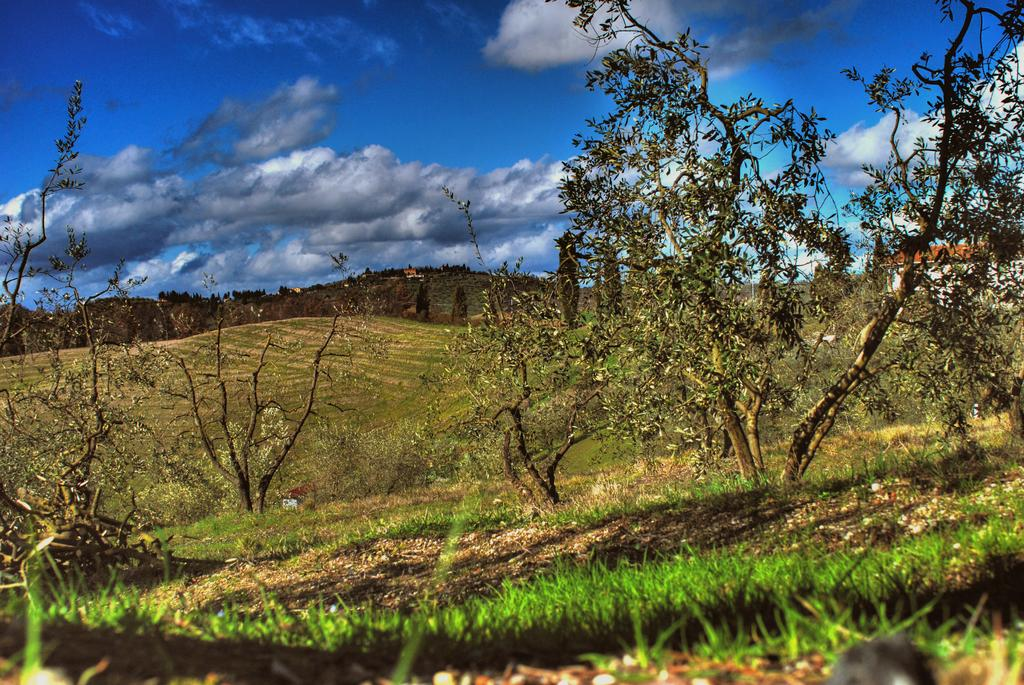What type of vegetation can be seen in the image? There are trees in the image. What is at the bottom of the image? There is grass at the bottom of the image. What geographical feature is present in the middle of the image? There are hills in the middle of the image. What can be seen in the sky in the image? There are clouds in the sky. What type of linen is draped over the square in the image? There is no linen or square present in the image. What song is being played in the background of the image? There is no audio or music present in the image, so it is not possible to determine what song might be playing. 